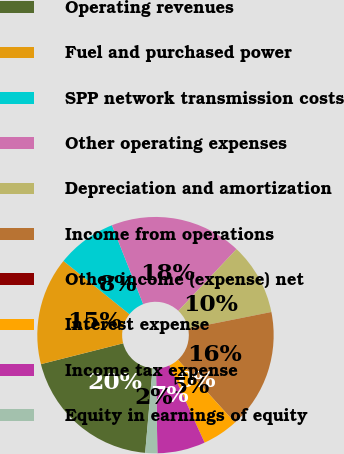Convert chart to OTSL. <chart><loc_0><loc_0><loc_500><loc_500><pie_chart><fcel>Operating revenues<fcel>Fuel and purchased power<fcel>SPP network transmission costs<fcel>Other operating expenses<fcel>Depreciation and amortization<fcel>Income from operations<fcel>Other income (expense) net<fcel>Interest expense<fcel>Income tax expense<fcel>Equity in earnings of equity<nl><fcel>19.66%<fcel>14.75%<fcel>8.2%<fcel>18.03%<fcel>9.84%<fcel>16.39%<fcel>0.01%<fcel>4.92%<fcel>6.56%<fcel>1.65%<nl></chart> 